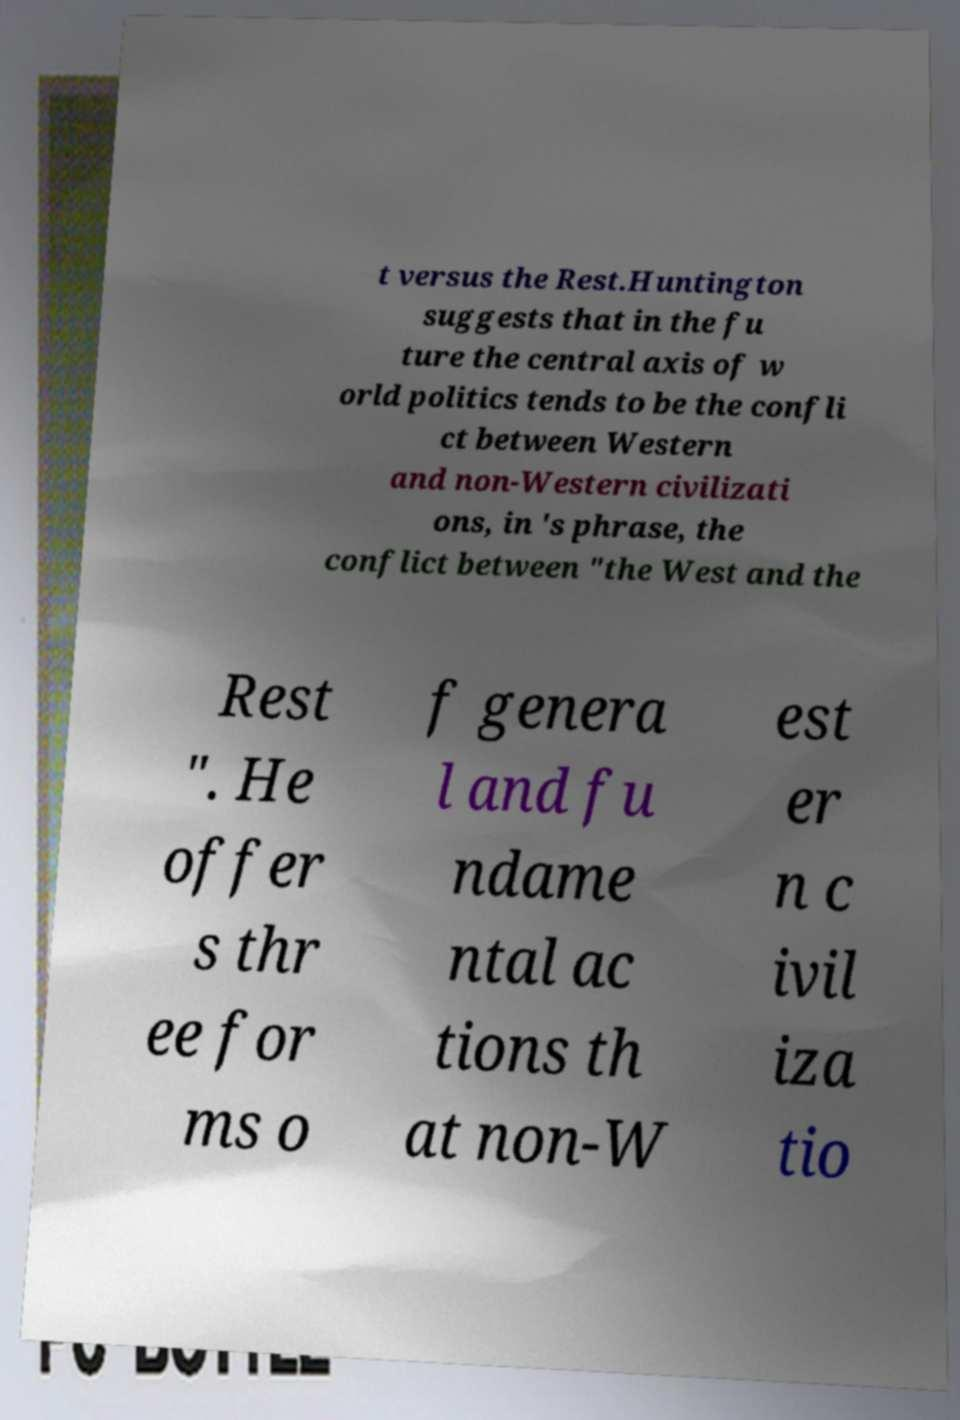Can you read and provide the text displayed in the image?This photo seems to have some interesting text. Can you extract and type it out for me? t versus the Rest.Huntington suggests that in the fu ture the central axis of w orld politics tends to be the confli ct between Western and non-Western civilizati ons, in 's phrase, the conflict between "the West and the Rest ". He offer s thr ee for ms o f genera l and fu ndame ntal ac tions th at non-W est er n c ivil iza tio 